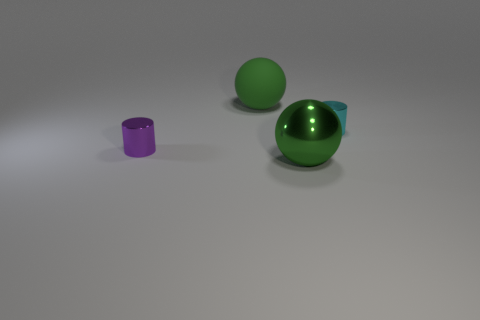Are there any purple shiny cylinders?
Provide a succinct answer. Yes. What color is the big thing that is right of the large ball that is behind the tiny cylinder that is behind the purple cylinder?
Your answer should be very brief. Green. There is a cylinder right of the green matte ball; are there any small objects that are in front of it?
Give a very brief answer. Yes. Do the large ball that is on the left side of the large metallic sphere and the small cylinder in front of the cyan cylinder have the same color?
Make the answer very short. No. How many cyan metallic cylinders have the same size as the purple thing?
Ensure brevity in your answer.  1. There is a metal cylinder right of the green shiny sphere; does it have the same size as the large green shiny thing?
Provide a short and direct response. No. The tiny cyan metallic object is what shape?
Make the answer very short. Cylinder. There is a thing that is the same color as the rubber ball; what size is it?
Your answer should be very brief. Large. Is the small object that is to the right of the matte sphere made of the same material as the small purple thing?
Your answer should be very brief. Yes. Is there a shiny object of the same color as the big rubber object?
Provide a short and direct response. Yes. 